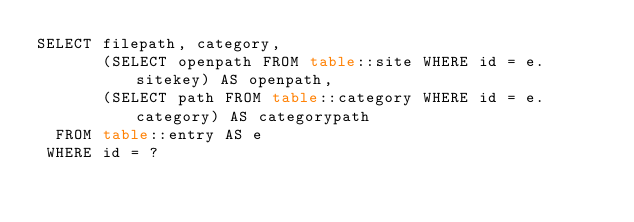Convert code to text. <code><loc_0><loc_0><loc_500><loc_500><_SQL_>SELECT filepath, category,
       (SELECT openpath FROM table::site WHERE id = e.sitekey) AS openpath,
       (SELECT path FROM table::category WHERE id = e.category) AS categorypath
  FROM table::entry AS e
 WHERE id = ?
</code> 